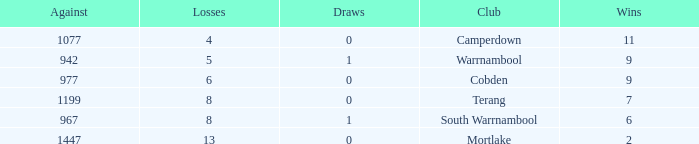How many draws did Mortlake have when the losses were more than 5? 1.0. Can you parse all the data within this table? {'header': ['Against', 'Losses', 'Draws', 'Club', 'Wins'], 'rows': [['1077', '4', '0', 'Camperdown', '11'], ['942', '5', '1', 'Warrnambool', '9'], ['977', '6', '0', 'Cobden', '9'], ['1199', '8', '0', 'Terang', '7'], ['967', '8', '1', 'South Warrnambool', '6'], ['1447', '13', '0', 'Mortlake', '2']]} 